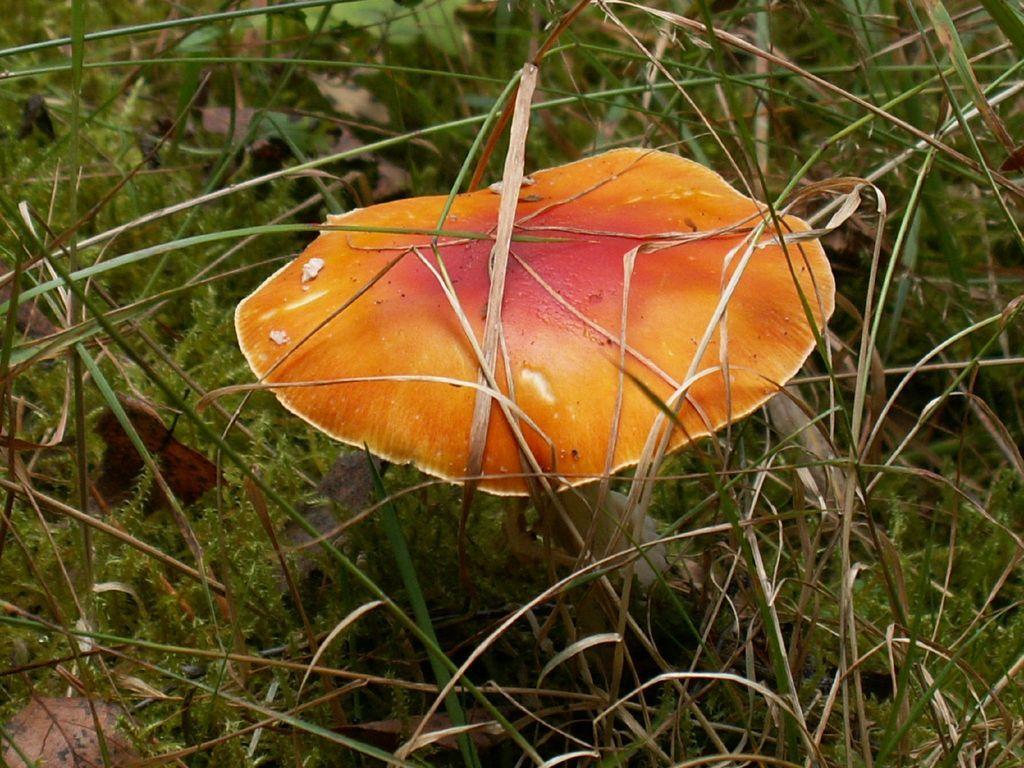In one or two sentences, can you explain what this image depicts? In the middle mushroom which is in orange color and this is the green color grass. 